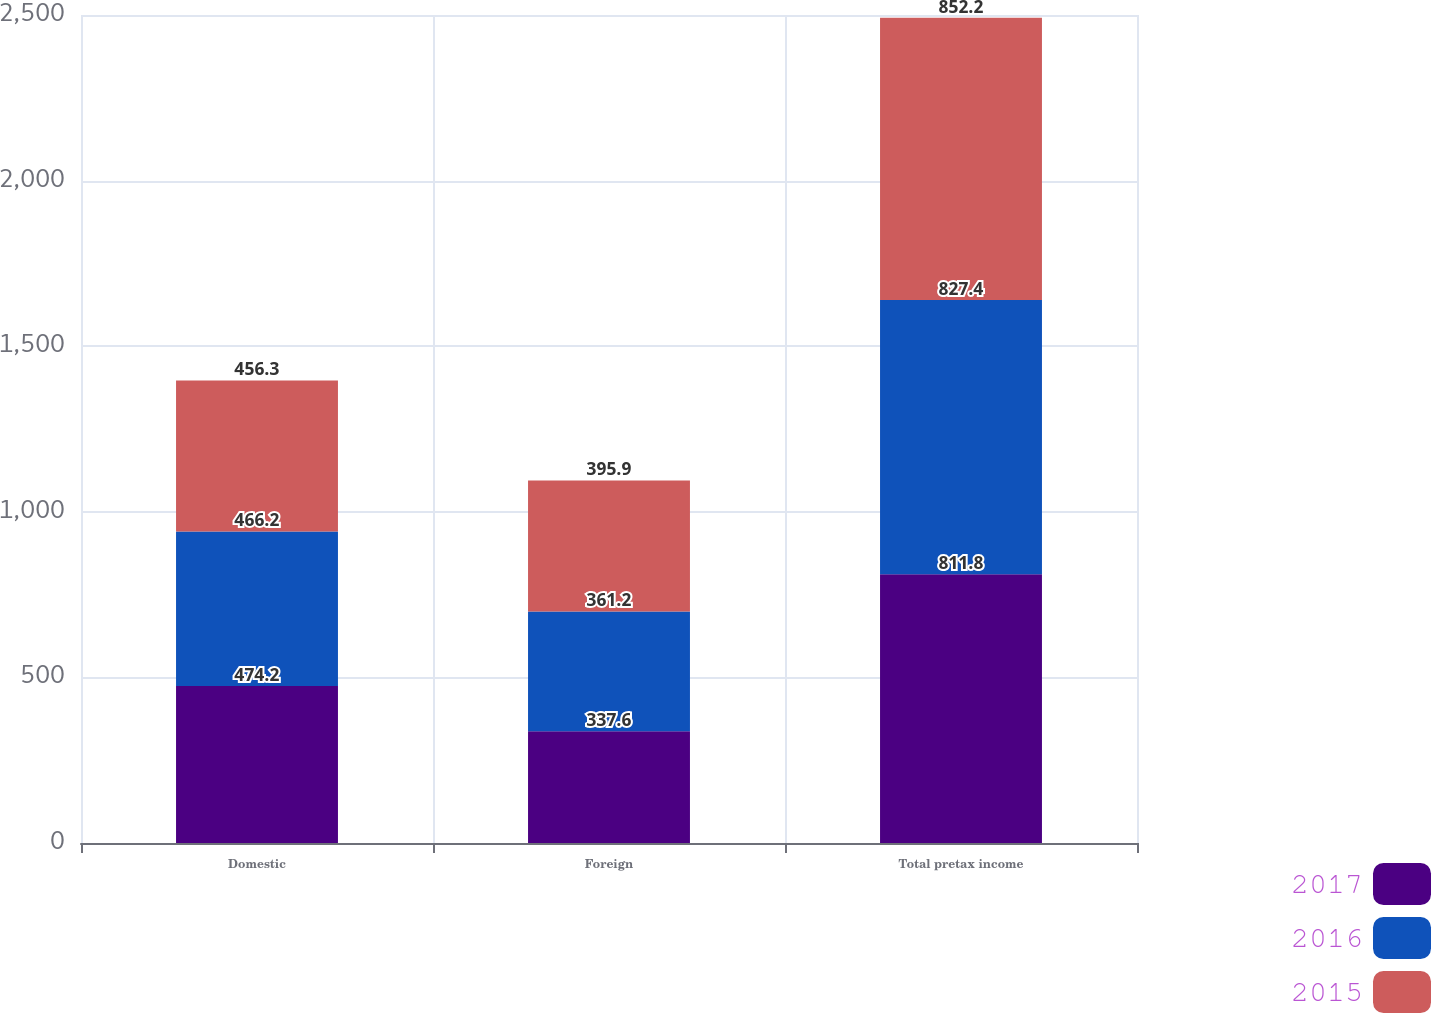Convert chart to OTSL. <chart><loc_0><loc_0><loc_500><loc_500><stacked_bar_chart><ecel><fcel>Domestic<fcel>Foreign<fcel>Total pretax income<nl><fcel>2017<fcel>474.2<fcel>337.6<fcel>811.8<nl><fcel>2016<fcel>466.2<fcel>361.2<fcel>827.4<nl><fcel>2015<fcel>456.3<fcel>395.9<fcel>852.2<nl></chart> 